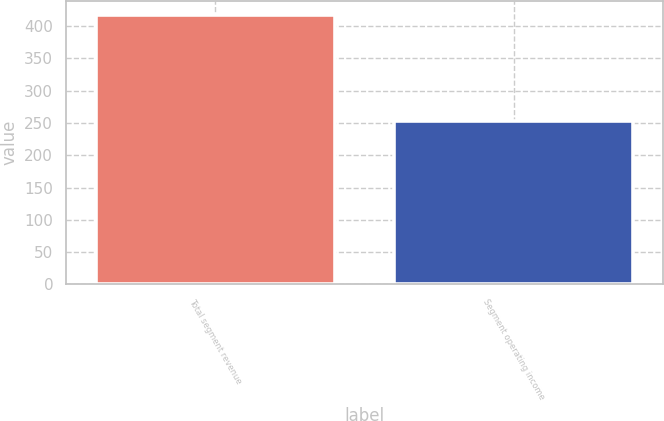Convert chart to OTSL. <chart><loc_0><loc_0><loc_500><loc_500><bar_chart><fcel>Total segment revenue<fcel>Segment operating income<nl><fcel>418<fcel>253<nl></chart> 